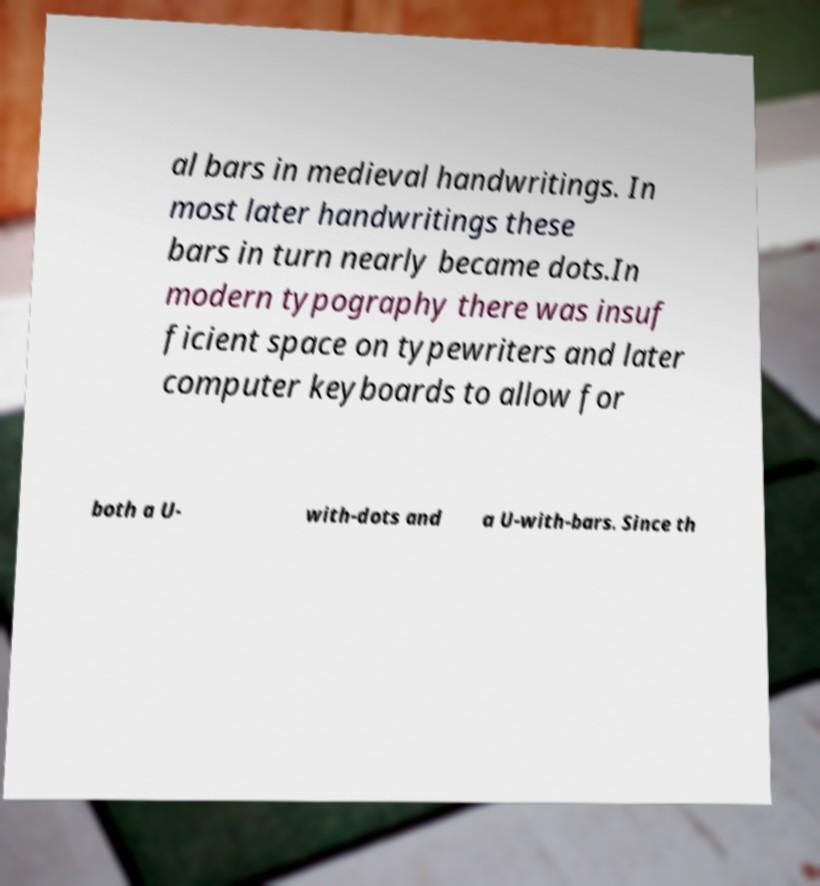Please identify and transcribe the text found in this image. al bars in medieval handwritings. In most later handwritings these bars in turn nearly became dots.In modern typography there was insuf ficient space on typewriters and later computer keyboards to allow for both a U- with-dots and a U-with-bars. Since th 